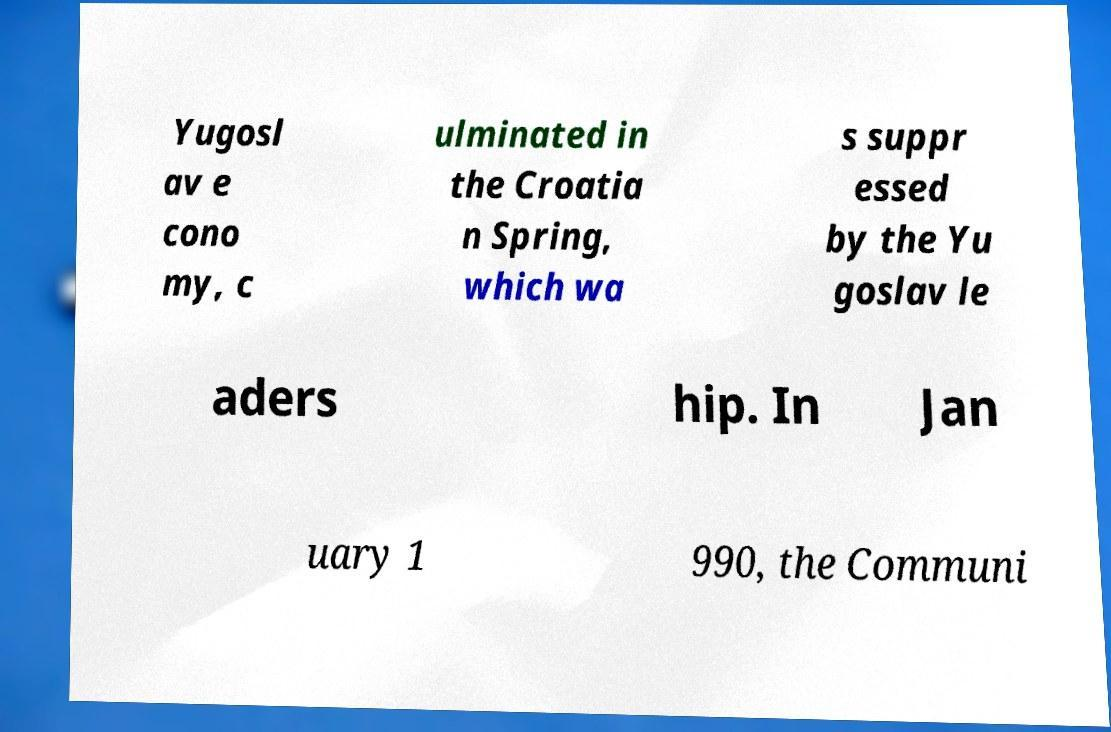Please identify and transcribe the text found in this image. Yugosl av e cono my, c ulminated in the Croatia n Spring, which wa s suppr essed by the Yu goslav le aders hip. In Jan uary 1 990, the Communi 